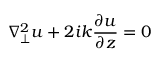Convert formula to latex. <formula><loc_0><loc_0><loc_500><loc_500>\nabla _ { \perp } ^ { 2 } u + 2 i k \frac { \partial u } { \partial z } = 0</formula> 